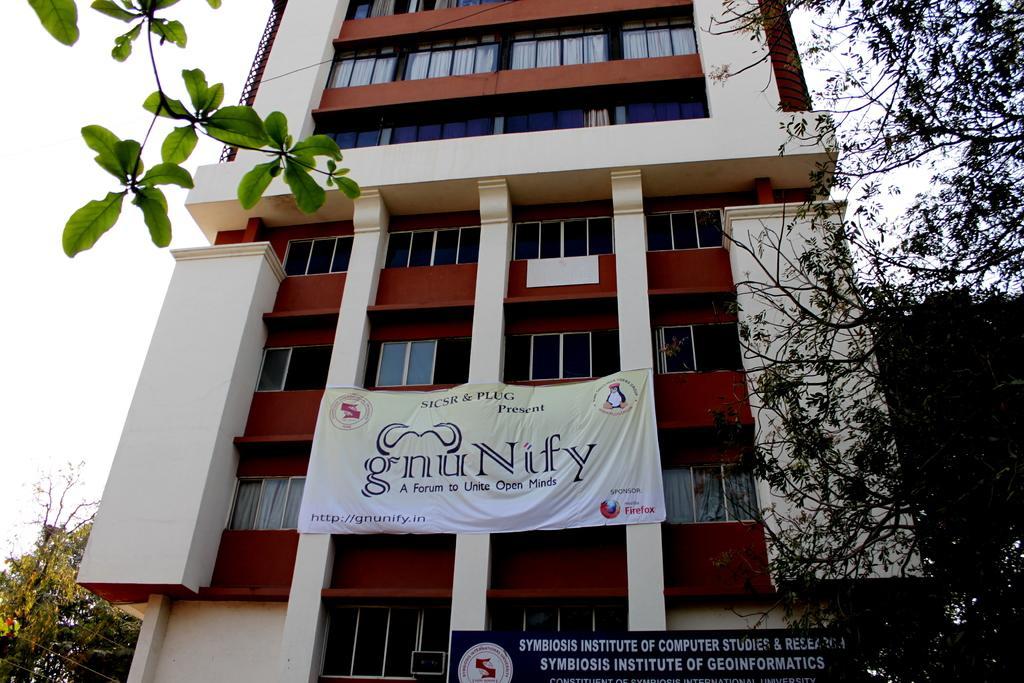Can you describe this image briefly? In this picture I can see a building, few trees and I can see a board and a banner with some text. I can see a cloudy sky. 